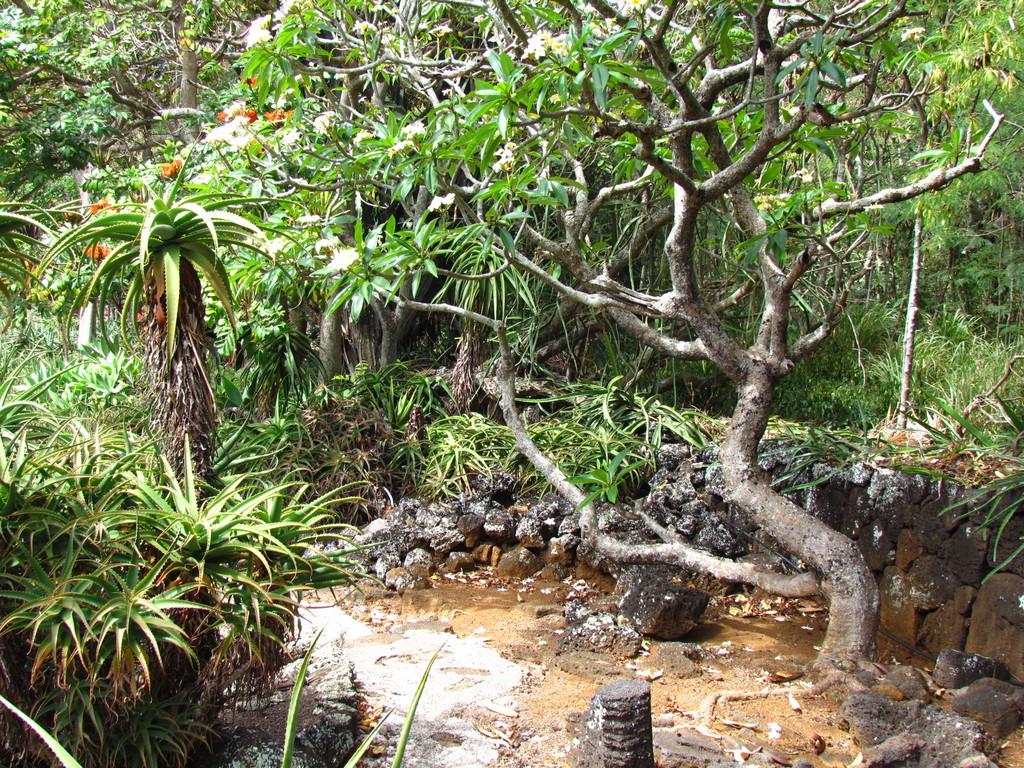What type of vegetation can be seen in the image? There are trees and plants in the image. What other natural elements are present in the image? There are rocks in the image. Can you see any fairies playing on the playground in the image? There are no fairies or playgrounds present in the image. What is located at the top of the trees in the image? The image does not show anything at the top of the trees, as it only depicts the trees, plants, and rocks. 